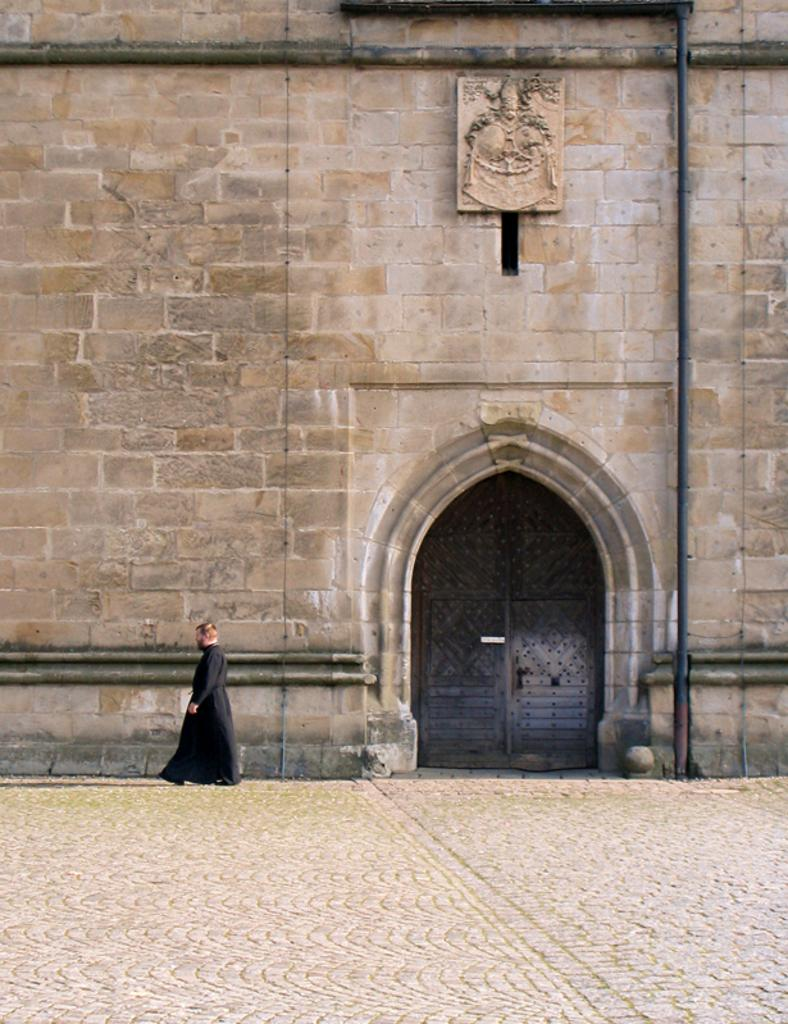What type of structure can be seen in the image? There is a wall in the image. Is there any entrance visible in the image? Yes, there is a door in the image. Can you describe the person in the image? There is a person in the image, but no specific details about their appearance or actions are provided. What other object can be seen in the image? There is a pipe in the image. What type of meal is being prepared by the person in the image? There is no indication of a meal or any cooking activity in the image. 